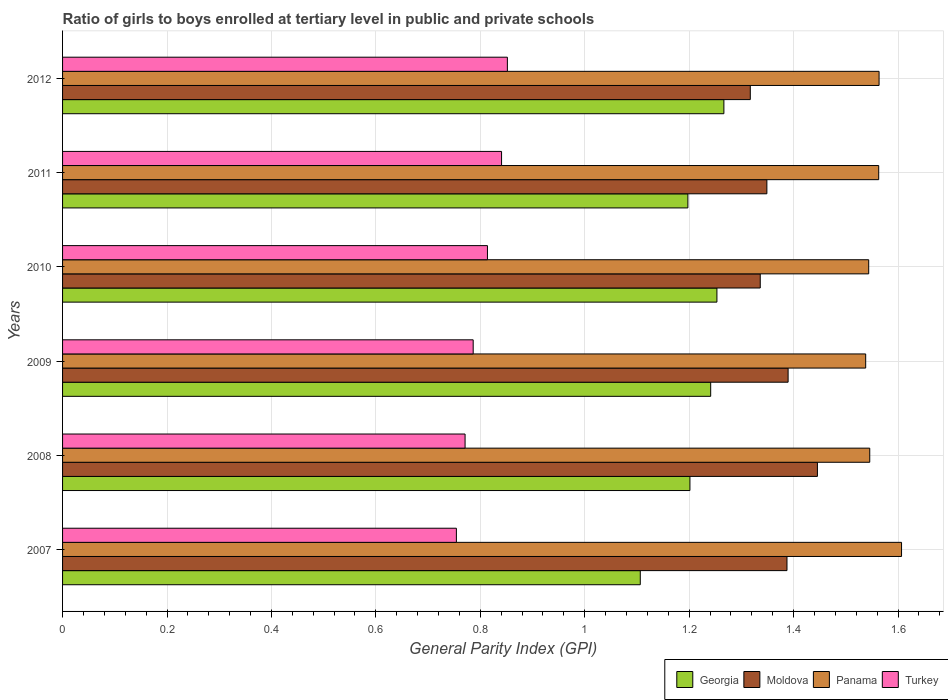How many different coloured bars are there?
Your response must be concise. 4. How many bars are there on the 5th tick from the top?
Ensure brevity in your answer.  4. How many bars are there on the 6th tick from the bottom?
Your response must be concise. 4. What is the label of the 1st group of bars from the top?
Offer a very short reply. 2012. In how many cases, is the number of bars for a given year not equal to the number of legend labels?
Make the answer very short. 0. What is the general parity index in Moldova in 2011?
Ensure brevity in your answer.  1.35. Across all years, what is the maximum general parity index in Moldova?
Make the answer very short. 1.45. Across all years, what is the minimum general parity index in Panama?
Make the answer very short. 1.54. In which year was the general parity index in Moldova maximum?
Keep it short and to the point. 2008. What is the total general parity index in Turkey in the graph?
Your answer should be compact. 4.82. What is the difference between the general parity index in Georgia in 2007 and that in 2012?
Offer a terse response. -0.16. What is the difference between the general parity index in Georgia in 2008 and the general parity index in Turkey in 2012?
Keep it short and to the point. 0.35. What is the average general parity index in Panama per year?
Provide a short and direct response. 1.56. In the year 2007, what is the difference between the general parity index in Georgia and general parity index in Turkey?
Your answer should be compact. 0.35. In how many years, is the general parity index in Moldova greater than 0.48000000000000004 ?
Provide a succinct answer. 6. What is the ratio of the general parity index in Georgia in 2007 to that in 2011?
Make the answer very short. 0.92. What is the difference between the highest and the second highest general parity index in Turkey?
Your response must be concise. 0.01. What is the difference between the highest and the lowest general parity index in Panama?
Give a very brief answer. 0.07. Is it the case that in every year, the sum of the general parity index in Georgia and general parity index in Moldova is greater than the sum of general parity index in Panama and general parity index in Turkey?
Provide a succinct answer. Yes. What does the 4th bar from the top in 2010 represents?
Provide a short and direct response. Georgia. What does the 2nd bar from the bottom in 2010 represents?
Offer a very short reply. Moldova. Are the values on the major ticks of X-axis written in scientific E-notation?
Your response must be concise. No. Does the graph contain any zero values?
Provide a succinct answer. No. Does the graph contain grids?
Provide a short and direct response. Yes. How are the legend labels stacked?
Offer a very short reply. Horizontal. What is the title of the graph?
Your answer should be compact. Ratio of girls to boys enrolled at tertiary level in public and private schools. What is the label or title of the X-axis?
Provide a short and direct response. General Parity Index (GPI). What is the label or title of the Y-axis?
Make the answer very short. Years. What is the General Parity Index (GPI) of Georgia in 2007?
Your answer should be compact. 1.11. What is the General Parity Index (GPI) in Moldova in 2007?
Make the answer very short. 1.39. What is the General Parity Index (GPI) in Panama in 2007?
Provide a short and direct response. 1.61. What is the General Parity Index (GPI) of Turkey in 2007?
Give a very brief answer. 0.75. What is the General Parity Index (GPI) in Georgia in 2008?
Make the answer very short. 1.2. What is the General Parity Index (GPI) in Moldova in 2008?
Keep it short and to the point. 1.45. What is the General Parity Index (GPI) of Panama in 2008?
Give a very brief answer. 1.55. What is the General Parity Index (GPI) in Turkey in 2008?
Your answer should be compact. 0.77. What is the General Parity Index (GPI) in Georgia in 2009?
Your answer should be compact. 1.24. What is the General Parity Index (GPI) of Moldova in 2009?
Offer a very short reply. 1.39. What is the General Parity Index (GPI) of Panama in 2009?
Your answer should be compact. 1.54. What is the General Parity Index (GPI) in Turkey in 2009?
Provide a short and direct response. 0.79. What is the General Parity Index (GPI) of Georgia in 2010?
Your response must be concise. 1.25. What is the General Parity Index (GPI) of Moldova in 2010?
Keep it short and to the point. 1.34. What is the General Parity Index (GPI) of Panama in 2010?
Your answer should be very brief. 1.54. What is the General Parity Index (GPI) in Turkey in 2010?
Give a very brief answer. 0.81. What is the General Parity Index (GPI) of Georgia in 2011?
Give a very brief answer. 1.2. What is the General Parity Index (GPI) of Moldova in 2011?
Offer a very short reply. 1.35. What is the General Parity Index (GPI) of Panama in 2011?
Ensure brevity in your answer.  1.56. What is the General Parity Index (GPI) in Turkey in 2011?
Offer a very short reply. 0.84. What is the General Parity Index (GPI) of Georgia in 2012?
Offer a very short reply. 1.27. What is the General Parity Index (GPI) in Moldova in 2012?
Your response must be concise. 1.32. What is the General Parity Index (GPI) of Panama in 2012?
Provide a succinct answer. 1.56. What is the General Parity Index (GPI) in Turkey in 2012?
Provide a short and direct response. 0.85. Across all years, what is the maximum General Parity Index (GPI) in Georgia?
Your response must be concise. 1.27. Across all years, what is the maximum General Parity Index (GPI) of Moldova?
Ensure brevity in your answer.  1.45. Across all years, what is the maximum General Parity Index (GPI) of Panama?
Offer a terse response. 1.61. Across all years, what is the maximum General Parity Index (GPI) in Turkey?
Provide a short and direct response. 0.85. Across all years, what is the minimum General Parity Index (GPI) in Georgia?
Offer a terse response. 1.11. Across all years, what is the minimum General Parity Index (GPI) in Moldova?
Provide a succinct answer. 1.32. Across all years, what is the minimum General Parity Index (GPI) of Panama?
Give a very brief answer. 1.54. Across all years, what is the minimum General Parity Index (GPI) in Turkey?
Provide a short and direct response. 0.75. What is the total General Parity Index (GPI) in Georgia in the graph?
Give a very brief answer. 7.27. What is the total General Parity Index (GPI) in Moldova in the graph?
Provide a succinct answer. 8.22. What is the total General Parity Index (GPI) of Panama in the graph?
Offer a terse response. 9.36. What is the total General Parity Index (GPI) in Turkey in the graph?
Provide a succinct answer. 4.82. What is the difference between the General Parity Index (GPI) of Georgia in 2007 and that in 2008?
Your response must be concise. -0.1. What is the difference between the General Parity Index (GPI) in Moldova in 2007 and that in 2008?
Your response must be concise. -0.06. What is the difference between the General Parity Index (GPI) of Panama in 2007 and that in 2008?
Your answer should be compact. 0.06. What is the difference between the General Parity Index (GPI) in Turkey in 2007 and that in 2008?
Make the answer very short. -0.02. What is the difference between the General Parity Index (GPI) of Georgia in 2007 and that in 2009?
Give a very brief answer. -0.13. What is the difference between the General Parity Index (GPI) of Moldova in 2007 and that in 2009?
Provide a succinct answer. -0. What is the difference between the General Parity Index (GPI) in Panama in 2007 and that in 2009?
Make the answer very short. 0.07. What is the difference between the General Parity Index (GPI) of Turkey in 2007 and that in 2009?
Offer a very short reply. -0.03. What is the difference between the General Parity Index (GPI) of Georgia in 2007 and that in 2010?
Ensure brevity in your answer.  -0.15. What is the difference between the General Parity Index (GPI) in Moldova in 2007 and that in 2010?
Provide a succinct answer. 0.05. What is the difference between the General Parity Index (GPI) in Panama in 2007 and that in 2010?
Your answer should be very brief. 0.06. What is the difference between the General Parity Index (GPI) of Turkey in 2007 and that in 2010?
Keep it short and to the point. -0.06. What is the difference between the General Parity Index (GPI) in Georgia in 2007 and that in 2011?
Offer a very short reply. -0.09. What is the difference between the General Parity Index (GPI) in Moldova in 2007 and that in 2011?
Give a very brief answer. 0.04. What is the difference between the General Parity Index (GPI) of Panama in 2007 and that in 2011?
Ensure brevity in your answer.  0.04. What is the difference between the General Parity Index (GPI) in Turkey in 2007 and that in 2011?
Your answer should be compact. -0.09. What is the difference between the General Parity Index (GPI) in Georgia in 2007 and that in 2012?
Make the answer very short. -0.16. What is the difference between the General Parity Index (GPI) in Moldova in 2007 and that in 2012?
Keep it short and to the point. 0.07. What is the difference between the General Parity Index (GPI) of Panama in 2007 and that in 2012?
Make the answer very short. 0.04. What is the difference between the General Parity Index (GPI) in Turkey in 2007 and that in 2012?
Your response must be concise. -0.1. What is the difference between the General Parity Index (GPI) in Georgia in 2008 and that in 2009?
Give a very brief answer. -0.04. What is the difference between the General Parity Index (GPI) in Moldova in 2008 and that in 2009?
Offer a terse response. 0.06. What is the difference between the General Parity Index (GPI) of Panama in 2008 and that in 2009?
Give a very brief answer. 0.01. What is the difference between the General Parity Index (GPI) in Turkey in 2008 and that in 2009?
Make the answer very short. -0.02. What is the difference between the General Parity Index (GPI) in Georgia in 2008 and that in 2010?
Ensure brevity in your answer.  -0.05. What is the difference between the General Parity Index (GPI) of Moldova in 2008 and that in 2010?
Ensure brevity in your answer.  0.11. What is the difference between the General Parity Index (GPI) in Panama in 2008 and that in 2010?
Ensure brevity in your answer.  0. What is the difference between the General Parity Index (GPI) in Turkey in 2008 and that in 2010?
Your answer should be compact. -0.04. What is the difference between the General Parity Index (GPI) of Georgia in 2008 and that in 2011?
Your answer should be compact. 0. What is the difference between the General Parity Index (GPI) of Moldova in 2008 and that in 2011?
Provide a short and direct response. 0.1. What is the difference between the General Parity Index (GPI) in Panama in 2008 and that in 2011?
Ensure brevity in your answer.  -0.02. What is the difference between the General Parity Index (GPI) of Turkey in 2008 and that in 2011?
Give a very brief answer. -0.07. What is the difference between the General Parity Index (GPI) in Georgia in 2008 and that in 2012?
Your answer should be compact. -0.07. What is the difference between the General Parity Index (GPI) of Moldova in 2008 and that in 2012?
Offer a terse response. 0.13. What is the difference between the General Parity Index (GPI) of Panama in 2008 and that in 2012?
Your answer should be very brief. -0.02. What is the difference between the General Parity Index (GPI) in Turkey in 2008 and that in 2012?
Make the answer very short. -0.08. What is the difference between the General Parity Index (GPI) in Georgia in 2009 and that in 2010?
Ensure brevity in your answer.  -0.01. What is the difference between the General Parity Index (GPI) of Moldova in 2009 and that in 2010?
Your answer should be very brief. 0.05. What is the difference between the General Parity Index (GPI) in Panama in 2009 and that in 2010?
Provide a succinct answer. -0.01. What is the difference between the General Parity Index (GPI) of Turkey in 2009 and that in 2010?
Your answer should be compact. -0.03. What is the difference between the General Parity Index (GPI) in Georgia in 2009 and that in 2011?
Your answer should be very brief. 0.04. What is the difference between the General Parity Index (GPI) in Moldova in 2009 and that in 2011?
Ensure brevity in your answer.  0.04. What is the difference between the General Parity Index (GPI) of Panama in 2009 and that in 2011?
Provide a succinct answer. -0.02. What is the difference between the General Parity Index (GPI) in Turkey in 2009 and that in 2011?
Offer a terse response. -0.05. What is the difference between the General Parity Index (GPI) in Georgia in 2009 and that in 2012?
Make the answer very short. -0.03. What is the difference between the General Parity Index (GPI) of Moldova in 2009 and that in 2012?
Provide a succinct answer. 0.07. What is the difference between the General Parity Index (GPI) in Panama in 2009 and that in 2012?
Your answer should be compact. -0.03. What is the difference between the General Parity Index (GPI) of Turkey in 2009 and that in 2012?
Give a very brief answer. -0.07. What is the difference between the General Parity Index (GPI) in Georgia in 2010 and that in 2011?
Offer a very short reply. 0.06. What is the difference between the General Parity Index (GPI) of Moldova in 2010 and that in 2011?
Your answer should be very brief. -0.01. What is the difference between the General Parity Index (GPI) of Panama in 2010 and that in 2011?
Provide a succinct answer. -0.02. What is the difference between the General Parity Index (GPI) of Turkey in 2010 and that in 2011?
Your answer should be compact. -0.03. What is the difference between the General Parity Index (GPI) in Georgia in 2010 and that in 2012?
Your answer should be compact. -0.01. What is the difference between the General Parity Index (GPI) of Moldova in 2010 and that in 2012?
Ensure brevity in your answer.  0.02. What is the difference between the General Parity Index (GPI) in Panama in 2010 and that in 2012?
Your answer should be compact. -0.02. What is the difference between the General Parity Index (GPI) of Turkey in 2010 and that in 2012?
Make the answer very short. -0.04. What is the difference between the General Parity Index (GPI) in Georgia in 2011 and that in 2012?
Keep it short and to the point. -0.07. What is the difference between the General Parity Index (GPI) of Moldova in 2011 and that in 2012?
Your response must be concise. 0.03. What is the difference between the General Parity Index (GPI) in Panama in 2011 and that in 2012?
Offer a terse response. -0. What is the difference between the General Parity Index (GPI) of Turkey in 2011 and that in 2012?
Provide a short and direct response. -0.01. What is the difference between the General Parity Index (GPI) in Georgia in 2007 and the General Parity Index (GPI) in Moldova in 2008?
Your response must be concise. -0.34. What is the difference between the General Parity Index (GPI) of Georgia in 2007 and the General Parity Index (GPI) of Panama in 2008?
Make the answer very short. -0.44. What is the difference between the General Parity Index (GPI) of Georgia in 2007 and the General Parity Index (GPI) of Turkey in 2008?
Offer a terse response. 0.34. What is the difference between the General Parity Index (GPI) in Moldova in 2007 and the General Parity Index (GPI) in Panama in 2008?
Provide a succinct answer. -0.16. What is the difference between the General Parity Index (GPI) in Moldova in 2007 and the General Parity Index (GPI) in Turkey in 2008?
Provide a succinct answer. 0.62. What is the difference between the General Parity Index (GPI) of Panama in 2007 and the General Parity Index (GPI) of Turkey in 2008?
Ensure brevity in your answer.  0.84. What is the difference between the General Parity Index (GPI) of Georgia in 2007 and the General Parity Index (GPI) of Moldova in 2009?
Offer a terse response. -0.28. What is the difference between the General Parity Index (GPI) in Georgia in 2007 and the General Parity Index (GPI) in Panama in 2009?
Offer a very short reply. -0.43. What is the difference between the General Parity Index (GPI) of Georgia in 2007 and the General Parity Index (GPI) of Turkey in 2009?
Your response must be concise. 0.32. What is the difference between the General Parity Index (GPI) of Moldova in 2007 and the General Parity Index (GPI) of Panama in 2009?
Make the answer very short. -0.15. What is the difference between the General Parity Index (GPI) in Moldova in 2007 and the General Parity Index (GPI) in Turkey in 2009?
Offer a very short reply. 0.6. What is the difference between the General Parity Index (GPI) in Panama in 2007 and the General Parity Index (GPI) in Turkey in 2009?
Your answer should be compact. 0.82. What is the difference between the General Parity Index (GPI) of Georgia in 2007 and the General Parity Index (GPI) of Moldova in 2010?
Offer a terse response. -0.23. What is the difference between the General Parity Index (GPI) of Georgia in 2007 and the General Parity Index (GPI) of Panama in 2010?
Give a very brief answer. -0.44. What is the difference between the General Parity Index (GPI) of Georgia in 2007 and the General Parity Index (GPI) of Turkey in 2010?
Provide a short and direct response. 0.29. What is the difference between the General Parity Index (GPI) in Moldova in 2007 and the General Parity Index (GPI) in Panama in 2010?
Provide a short and direct response. -0.16. What is the difference between the General Parity Index (GPI) in Moldova in 2007 and the General Parity Index (GPI) in Turkey in 2010?
Offer a terse response. 0.57. What is the difference between the General Parity Index (GPI) in Panama in 2007 and the General Parity Index (GPI) in Turkey in 2010?
Offer a terse response. 0.79. What is the difference between the General Parity Index (GPI) of Georgia in 2007 and the General Parity Index (GPI) of Moldova in 2011?
Keep it short and to the point. -0.24. What is the difference between the General Parity Index (GPI) of Georgia in 2007 and the General Parity Index (GPI) of Panama in 2011?
Make the answer very short. -0.46. What is the difference between the General Parity Index (GPI) of Georgia in 2007 and the General Parity Index (GPI) of Turkey in 2011?
Ensure brevity in your answer.  0.27. What is the difference between the General Parity Index (GPI) in Moldova in 2007 and the General Parity Index (GPI) in Panama in 2011?
Ensure brevity in your answer.  -0.18. What is the difference between the General Parity Index (GPI) in Moldova in 2007 and the General Parity Index (GPI) in Turkey in 2011?
Make the answer very short. 0.55. What is the difference between the General Parity Index (GPI) in Panama in 2007 and the General Parity Index (GPI) in Turkey in 2011?
Ensure brevity in your answer.  0.77. What is the difference between the General Parity Index (GPI) of Georgia in 2007 and the General Parity Index (GPI) of Moldova in 2012?
Provide a succinct answer. -0.21. What is the difference between the General Parity Index (GPI) of Georgia in 2007 and the General Parity Index (GPI) of Panama in 2012?
Provide a short and direct response. -0.46. What is the difference between the General Parity Index (GPI) in Georgia in 2007 and the General Parity Index (GPI) in Turkey in 2012?
Offer a very short reply. 0.25. What is the difference between the General Parity Index (GPI) in Moldova in 2007 and the General Parity Index (GPI) in Panama in 2012?
Ensure brevity in your answer.  -0.18. What is the difference between the General Parity Index (GPI) in Moldova in 2007 and the General Parity Index (GPI) in Turkey in 2012?
Offer a very short reply. 0.54. What is the difference between the General Parity Index (GPI) in Panama in 2007 and the General Parity Index (GPI) in Turkey in 2012?
Make the answer very short. 0.75. What is the difference between the General Parity Index (GPI) in Georgia in 2008 and the General Parity Index (GPI) in Moldova in 2009?
Ensure brevity in your answer.  -0.19. What is the difference between the General Parity Index (GPI) of Georgia in 2008 and the General Parity Index (GPI) of Panama in 2009?
Your response must be concise. -0.34. What is the difference between the General Parity Index (GPI) in Georgia in 2008 and the General Parity Index (GPI) in Turkey in 2009?
Your answer should be compact. 0.42. What is the difference between the General Parity Index (GPI) in Moldova in 2008 and the General Parity Index (GPI) in Panama in 2009?
Make the answer very short. -0.09. What is the difference between the General Parity Index (GPI) in Moldova in 2008 and the General Parity Index (GPI) in Turkey in 2009?
Provide a short and direct response. 0.66. What is the difference between the General Parity Index (GPI) of Panama in 2008 and the General Parity Index (GPI) of Turkey in 2009?
Make the answer very short. 0.76. What is the difference between the General Parity Index (GPI) of Georgia in 2008 and the General Parity Index (GPI) of Moldova in 2010?
Offer a terse response. -0.13. What is the difference between the General Parity Index (GPI) of Georgia in 2008 and the General Parity Index (GPI) of Panama in 2010?
Ensure brevity in your answer.  -0.34. What is the difference between the General Parity Index (GPI) of Georgia in 2008 and the General Parity Index (GPI) of Turkey in 2010?
Offer a terse response. 0.39. What is the difference between the General Parity Index (GPI) in Moldova in 2008 and the General Parity Index (GPI) in Panama in 2010?
Provide a succinct answer. -0.1. What is the difference between the General Parity Index (GPI) of Moldova in 2008 and the General Parity Index (GPI) of Turkey in 2010?
Give a very brief answer. 0.63. What is the difference between the General Parity Index (GPI) in Panama in 2008 and the General Parity Index (GPI) in Turkey in 2010?
Offer a very short reply. 0.73. What is the difference between the General Parity Index (GPI) in Georgia in 2008 and the General Parity Index (GPI) in Moldova in 2011?
Provide a succinct answer. -0.15. What is the difference between the General Parity Index (GPI) of Georgia in 2008 and the General Parity Index (GPI) of Panama in 2011?
Ensure brevity in your answer.  -0.36. What is the difference between the General Parity Index (GPI) in Georgia in 2008 and the General Parity Index (GPI) in Turkey in 2011?
Make the answer very short. 0.36. What is the difference between the General Parity Index (GPI) of Moldova in 2008 and the General Parity Index (GPI) of Panama in 2011?
Offer a very short reply. -0.12. What is the difference between the General Parity Index (GPI) in Moldova in 2008 and the General Parity Index (GPI) in Turkey in 2011?
Give a very brief answer. 0.6. What is the difference between the General Parity Index (GPI) of Panama in 2008 and the General Parity Index (GPI) of Turkey in 2011?
Offer a terse response. 0.71. What is the difference between the General Parity Index (GPI) in Georgia in 2008 and the General Parity Index (GPI) in Moldova in 2012?
Provide a succinct answer. -0.12. What is the difference between the General Parity Index (GPI) of Georgia in 2008 and the General Parity Index (GPI) of Panama in 2012?
Ensure brevity in your answer.  -0.36. What is the difference between the General Parity Index (GPI) in Georgia in 2008 and the General Parity Index (GPI) in Turkey in 2012?
Your answer should be very brief. 0.35. What is the difference between the General Parity Index (GPI) in Moldova in 2008 and the General Parity Index (GPI) in Panama in 2012?
Offer a very short reply. -0.12. What is the difference between the General Parity Index (GPI) in Moldova in 2008 and the General Parity Index (GPI) in Turkey in 2012?
Provide a succinct answer. 0.59. What is the difference between the General Parity Index (GPI) in Panama in 2008 and the General Parity Index (GPI) in Turkey in 2012?
Your answer should be compact. 0.69. What is the difference between the General Parity Index (GPI) of Georgia in 2009 and the General Parity Index (GPI) of Moldova in 2010?
Your answer should be compact. -0.09. What is the difference between the General Parity Index (GPI) in Georgia in 2009 and the General Parity Index (GPI) in Panama in 2010?
Give a very brief answer. -0.3. What is the difference between the General Parity Index (GPI) of Georgia in 2009 and the General Parity Index (GPI) of Turkey in 2010?
Offer a very short reply. 0.43. What is the difference between the General Parity Index (GPI) of Moldova in 2009 and the General Parity Index (GPI) of Panama in 2010?
Keep it short and to the point. -0.15. What is the difference between the General Parity Index (GPI) in Moldova in 2009 and the General Parity Index (GPI) in Turkey in 2010?
Your response must be concise. 0.58. What is the difference between the General Parity Index (GPI) of Panama in 2009 and the General Parity Index (GPI) of Turkey in 2010?
Give a very brief answer. 0.72. What is the difference between the General Parity Index (GPI) in Georgia in 2009 and the General Parity Index (GPI) in Moldova in 2011?
Give a very brief answer. -0.11. What is the difference between the General Parity Index (GPI) in Georgia in 2009 and the General Parity Index (GPI) in Panama in 2011?
Offer a very short reply. -0.32. What is the difference between the General Parity Index (GPI) of Georgia in 2009 and the General Parity Index (GPI) of Turkey in 2011?
Provide a succinct answer. 0.4. What is the difference between the General Parity Index (GPI) of Moldova in 2009 and the General Parity Index (GPI) of Panama in 2011?
Make the answer very short. -0.17. What is the difference between the General Parity Index (GPI) in Moldova in 2009 and the General Parity Index (GPI) in Turkey in 2011?
Ensure brevity in your answer.  0.55. What is the difference between the General Parity Index (GPI) of Panama in 2009 and the General Parity Index (GPI) of Turkey in 2011?
Your response must be concise. 0.7. What is the difference between the General Parity Index (GPI) of Georgia in 2009 and the General Parity Index (GPI) of Moldova in 2012?
Your answer should be compact. -0.08. What is the difference between the General Parity Index (GPI) of Georgia in 2009 and the General Parity Index (GPI) of Panama in 2012?
Your answer should be compact. -0.32. What is the difference between the General Parity Index (GPI) of Georgia in 2009 and the General Parity Index (GPI) of Turkey in 2012?
Your response must be concise. 0.39. What is the difference between the General Parity Index (GPI) of Moldova in 2009 and the General Parity Index (GPI) of Panama in 2012?
Make the answer very short. -0.17. What is the difference between the General Parity Index (GPI) in Moldova in 2009 and the General Parity Index (GPI) in Turkey in 2012?
Offer a terse response. 0.54. What is the difference between the General Parity Index (GPI) in Panama in 2009 and the General Parity Index (GPI) in Turkey in 2012?
Provide a succinct answer. 0.69. What is the difference between the General Parity Index (GPI) of Georgia in 2010 and the General Parity Index (GPI) of Moldova in 2011?
Offer a terse response. -0.1. What is the difference between the General Parity Index (GPI) of Georgia in 2010 and the General Parity Index (GPI) of Panama in 2011?
Provide a short and direct response. -0.31. What is the difference between the General Parity Index (GPI) in Georgia in 2010 and the General Parity Index (GPI) in Turkey in 2011?
Offer a terse response. 0.41. What is the difference between the General Parity Index (GPI) of Moldova in 2010 and the General Parity Index (GPI) of Panama in 2011?
Your answer should be compact. -0.23. What is the difference between the General Parity Index (GPI) of Moldova in 2010 and the General Parity Index (GPI) of Turkey in 2011?
Keep it short and to the point. 0.5. What is the difference between the General Parity Index (GPI) in Panama in 2010 and the General Parity Index (GPI) in Turkey in 2011?
Your answer should be very brief. 0.7. What is the difference between the General Parity Index (GPI) in Georgia in 2010 and the General Parity Index (GPI) in Moldova in 2012?
Give a very brief answer. -0.06. What is the difference between the General Parity Index (GPI) in Georgia in 2010 and the General Parity Index (GPI) in Panama in 2012?
Make the answer very short. -0.31. What is the difference between the General Parity Index (GPI) in Georgia in 2010 and the General Parity Index (GPI) in Turkey in 2012?
Your response must be concise. 0.4. What is the difference between the General Parity Index (GPI) of Moldova in 2010 and the General Parity Index (GPI) of Panama in 2012?
Keep it short and to the point. -0.23. What is the difference between the General Parity Index (GPI) of Moldova in 2010 and the General Parity Index (GPI) of Turkey in 2012?
Your response must be concise. 0.48. What is the difference between the General Parity Index (GPI) in Panama in 2010 and the General Parity Index (GPI) in Turkey in 2012?
Keep it short and to the point. 0.69. What is the difference between the General Parity Index (GPI) of Georgia in 2011 and the General Parity Index (GPI) of Moldova in 2012?
Ensure brevity in your answer.  -0.12. What is the difference between the General Parity Index (GPI) of Georgia in 2011 and the General Parity Index (GPI) of Panama in 2012?
Offer a very short reply. -0.37. What is the difference between the General Parity Index (GPI) in Georgia in 2011 and the General Parity Index (GPI) in Turkey in 2012?
Provide a succinct answer. 0.35. What is the difference between the General Parity Index (GPI) in Moldova in 2011 and the General Parity Index (GPI) in Panama in 2012?
Ensure brevity in your answer.  -0.21. What is the difference between the General Parity Index (GPI) in Moldova in 2011 and the General Parity Index (GPI) in Turkey in 2012?
Make the answer very short. 0.5. What is the difference between the General Parity Index (GPI) in Panama in 2011 and the General Parity Index (GPI) in Turkey in 2012?
Provide a short and direct response. 0.71. What is the average General Parity Index (GPI) in Georgia per year?
Your answer should be very brief. 1.21. What is the average General Parity Index (GPI) of Moldova per year?
Offer a terse response. 1.37. What is the average General Parity Index (GPI) of Panama per year?
Ensure brevity in your answer.  1.56. What is the average General Parity Index (GPI) in Turkey per year?
Your answer should be compact. 0.8. In the year 2007, what is the difference between the General Parity Index (GPI) of Georgia and General Parity Index (GPI) of Moldova?
Make the answer very short. -0.28. In the year 2007, what is the difference between the General Parity Index (GPI) in Georgia and General Parity Index (GPI) in Panama?
Provide a short and direct response. -0.5. In the year 2007, what is the difference between the General Parity Index (GPI) in Georgia and General Parity Index (GPI) in Turkey?
Give a very brief answer. 0.35. In the year 2007, what is the difference between the General Parity Index (GPI) in Moldova and General Parity Index (GPI) in Panama?
Ensure brevity in your answer.  -0.22. In the year 2007, what is the difference between the General Parity Index (GPI) in Moldova and General Parity Index (GPI) in Turkey?
Your answer should be compact. 0.63. In the year 2007, what is the difference between the General Parity Index (GPI) of Panama and General Parity Index (GPI) of Turkey?
Give a very brief answer. 0.85. In the year 2008, what is the difference between the General Parity Index (GPI) of Georgia and General Parity Index (GPI) of Moldova?
Give a very brief answer. -0.24. In the year 2008, what is the difference between the General Parity Index (GPI) in Georgia and General Parity Index (GPI) in Panama?
Give a very brief answer. -0.34. In the year 2008, what is the difference between the General Parity Index (GPI) in Georgia and General Parity Index (GPI) in Turkey?
Give a very brief answer. 0.43. In the year 2008, what is the difference between the General Parity Index (GPI) in Moldova and General Parity Index (GPI) in Panama?
Ensure brevity in your answer.  -0.1. In the year 2008, what is the difference between the General Parity Index (GPI) of Moldova and General Parity Index (GPI) of Turkey?
Ensure brevity in your answer.  0.67. In the year 2008, what is the difference between the General Parity Index (GPI) of Panama and General Parity Index (GPI) of Turkey?
Offer a very short reply. 0.78. In the year 2009, what is the difference between the General Parity Index (GPI) of Georgia and General Parity Index (GPI) of Moldova?
Your answer should be very brief. -0.15. In the year 2009, what is the difference between the General Parity Index (GPI) in Georgia and General Parity Index (GPI) in Panama?
Offer a terse response. -0.3. In the year 2009, what is the difference between the General Parity Index (GPI) of Georgia and General Parity Index (GPI) of Turkey?
Your answer should be very brief. 0.45. In the year 2009, what is the difference between the General Parity Index (GPI) of Moldova and General Parity Index (GPI) of Panama?
Keep it short and to the point. -0.15. In the year 2009, what is the difference between the General Parity Index (GPI) of Moldova and General Parity Index (GPI) of Turkey?
Give a very brief answer. 0.6. In the year 2009, what is the difference between the General Parity Index (GPI) in Panama and General Parity Index (GPI) in Turkey?
Your answer should be very brief. 0.75. In the year 2010, what is the difference between the General Parity Index (GPI) in Georgia and General Parity Index (GPI) in Moldova?
Provide a short and direct response. -0.08. In the year 2010, what is the difference between the General Parity Index (GPI) of Georgia and General Parity Index (GPI) of Panama?
Give a very brief answer. -0.29. In the year 2010, what is the difference between the General Parity Index (GPI) of Georgia and General Parity Index (GPI) of Turkey?
Provide a succinct answer. 0.44. In the year 2010, what is the difference between the General Parity Index (GPI) in Moldova and General Parity Index (GPI) in Panama?
Your response must be concise. -0.21. In the year 2010, what is the difference between the General Parity Index (GPI) of Moldova and General Parity Index (GPI) of Turkey?
Keep it short and to the point. 0.52. In the year 2010, what is the difference between the General Parity Index (GPI) of Panama and General Parity Index (GPI) of Turkey?
Ensure brevity in your answer.  0.73. In the year 2011, what is the difference between the General Parity Index (GPI) in Georgia and General Parity Index (GPI) in Moldova?
Make the answer very short. -0.15. In the year 2011, what is the difference between the General Parity Index (GPI) in Georgia and General Parity Index (GPI) in Panama?
Your response must be concise. -0.37. In the year 2011, what is the difference between the General Parity Index (GPI) in Georgia and General Parity Index (GPI) in Turkey?
Give a very brief answer. 0.36. In the year 2011, what is the difference between the General Parity Index (GPI) in Moldova and General Parity Index (GPI) in Panama?
Offer a terse response. -0.21. In the year 2011, what is the difference between the General Parity Index (GPI) in Moldova and General Parity Index (GPI) in Turkey?
Give a very brief answer. 0.51. In the year 2011, what is the difference between the General Parity Index (GPI) of Panama and General Parity Index (GPI) of Turkey?
Your answer should be very brief. 0.72. In the year 2012, what is the difference between the General Parity Index (GPI) of Georgia and General Parity Index (GPI) of Moldova?
Your answer should be very brief. -0.05. In the year 2012, what is the difference between the General Parity Index (GPI) in Georgia and General Parity Index (GPI) in Panama?
Offer a very short reply. -0.3. In the year 2012, what is the difference between the General Parity Index (GPI) of Georgia and General Parity Index (GPI) of Turkey?
Offer a very short reply. 0.41. In the year 2012, what is the difference between the General Parity Index (GPI) in Moldova and General Parity Index (GPI) in Panama?
Ensure brevity in your answer.  -0.25. In the year 2012, what is the difference between the General Parity Index (GPI) in Moldova and General Parity Index (GPI) in Turkey?
Provide a short and direct response. 0.47. In the year 2012, what is the difference between the General Parity Index (GPI) of Panama and General Parity Index (GPI) of Turkey?
Your answer should be compact. 0.71. What is the ratio of the General Parity Index (GPI) in Georgia in 2007 to that in 2008?
Make the answer very short. 0.92. What is the ratio of the General Parity Index (GPI) of Moldova in 2007 to that in 2008?
Give a very brief answer. 0.96. What is the ratio of the General Parity Index (GPI) in Panama in 2007 to that in 2008?
Make the answer very short. 1.04. What is the ratio of the General Parity Index (GPI) of Turkey in 2007 to that in 2008?
Your answer should be compact. 0.98. What is the ratio of the General Parity Index (GPI) in Georgia in 2007 to that in 2009?
Your answer should be very brief. 0.89. What is the ratio of the General Parity Index (GPI) of Moldova in 2007 to that in 2009?
Provide a short and direct response. 1. What is the ratio of the General Parity Index (GPI) in Panama in 2007 to that in 2009?
Provide a short and direct response. 1.04. What is the ratio of the General Parity Index (GPI) in Turkey in 2007 to that in 2009?
Ensure brevity in your answer.  0.96. What is the ratio of the General Parity Index (GPI) of Georgia in 2007 to that in 2010?
Your response must be concise. 0.88. What is the ratio of the General Parity Index (GPI) in Moldova in 2007 to that in 2010?
Offer a very short reply. 1.04. What is the ratio of the General Parity Index (GPI) in Panama in 2007 to that in 2010?
Offer a very short reply. 1.04. What is the ratio of the General Parity Index (GPI) in Turkey in 2007 to that in 2010?
Ensure brevity in your answer.  0.93. What is the ratio of the General Parity Index (GPI) in Georgia in 2007 to that in 2011?
Provide a succinct answer. 0.92. What is the ratio of the General Parity Index (GPI) of Moldova in 2007 to that in 2011?
Offer a very short reply. 1.03. What is the ratio of the General Parity Index (GPI) in Panama in 2007 to that in 2011?
Provide a succinct answer. 1.03. What is the ratio of the General Parity Index (GPI) in Turkey in 2007 to that in 2011?
Your answer should be compact. 0.9. What is the ratio of the General Parity Index (GPI) of Georgia in 2007 to that in 2012?
Give a very brief answer. 0.87. What is the ratio of the General Parity Index (GPI) in Moldova in 2007 to that in 2012?
Give a very brief answer. 1.05. What is the ratio of the General Parity Index (GPI) of Panama in 2007 to that in 2012?
Offer a terse response. 1.03. What is the ratio of the General Parity Index (GPI) in Turkey in 2007 to that in 2012?
Offer a very short reply. 0.89. What is the ratio of the General Parity Index (GPI) of Georgia in 2008 to that in 2009?
Your response must be concise. 0.97. What is the ratio of the General Parity Index (GPI) of Moldova in 2008 to that in 2009?
Your response must be concise. 1.04. What is the ratio of the General Parity Index (GPI) of Panama in 2008 to that in 2009?
Keep it short and to the point. 1.01. What is the ratio of the General Parity Index (GPI) in Turkey in 2008 to that in 2009?
Make the answer very short. 0.98. What is the ratio of the General Parity Index (GPI) of Georgia in 2008 to that in 2010?
Ensure brevity in your answer.  0.96. What is the ratio of the General Parity Index (GPI) of Moldova in 2008 to that in 2010?
Provide a short and direct response. 1.08. What is the ratio of the General Parity Index (GPI) in Panama in 2008 to that in 2010?
Provide a short and direct response. 1. What is the ratio of the General Parity Index (GPI) in Turkey in 2008 to that in 2010?
Ensure brevity in your answer.  0.95. What is the ratio of the General Parity Index (GPI) of Georgia in 2008 to that in 2011?
Keep it short and to the point. 1. What is the ratio of the General Parity Index (GPI) of Moldova in 2008 to that in 2011?
Ensure brevity in your answer.  1.07. What is the ratio of the General Parity Index (GPI) in Panama in 2008 to that in 2011?
Your answer should be compact. 0.99. What is the ratio of the General Parity Index (GPI) of Turkey in 2008 to that in 2011?
Your answer should be very brief. 0.92. What is the ratio of the General Parity Index (GPI) of Georgia in 2008 to that in 2012?
Make the answer very short. 0.95. What is the ratio of the General Parity Index (GPI) in Moldova in 2008 to that in 2012?
Offer a terse response. 1.1. What is the ratio of the General Parity Index (GPI) of Turkey in 2008 to that in 2012?
Your response must be concise. 0.9. What is the ratio of the General Parity Index (GPI) of Georgia in 2009 to that in 2010?
Keep it short and to the point. 0.99. What is the ratio of the General Parity Index (GPI) in Moldova in 2009 to that in 2010?
Offer a terse response. 1.04. What is the ratio of the General Parity Index (GPI) of Panama in 2009 to that in 2010?
Make the answer very short. 1. What is the ratio of the General Parity Index (GPI) of Turkey in 2009 to that in 2010?
Make the answer very short. 0.97. What is the ratio of the General Parity Index (GPI) in Georgia in 2009 to that in 2011?
Your answer should be compact. 1.04. What is the ratio of the General Parity Index (GPI) in Moldova in 2009 to that in 2011?
Make the answer very short. 1.03. What is the ratio of the General Parity Index (GPI) of Panama in 2009 to that in 2011?
Give a very brief answer. 0.98. What is the ratio of the General Parity Index (GPI) of Turkey in 2009 to that in 2011?
Your response must be concise. 0.94. What is the ratio of the General Parity Index (GPI) of Georgia in 2009 to that in 2012?
Your response must be concise. 0.98. What is the ratio of the General Parity Index (GPI) of Moldova in 2009 to that in 2012?
Offer a very short reply. 1.05. What is the ratio of the General Parity Index (GPI) in Panama in 2009 to that in 2012?
Your answer should be compact. 0.98. What is the ratio of the General Parity Index (GPI) of Georgia in 2010 to that in 2011?
Offer a very short reply. 1.05. What is the ratio of the General Parity Index (GPI) of Moldova in 2010 to that in 2011?
Offer a terse response. 0.99. What is the ratio of the General Parity Index (GPI) of Panama in 2010 to that in 2011?
Offer a very short reply. 0.99. What is the ratio of the General Parity Index (GPI) of Turkey in 2010 to that in 2011?
Provide a short and direct response. 0.97. What is the ratio of the General Parity Index (GPI) in Georgia in 2010 to that in 2012?
Keep it short and to the point. 0.99. What is the ratio of the General Parity Index (GPI) of Moldova in 2010 to that in 2012?
Offer a very short reply. 1.01. What is the ratio of the General Parity Index (GPI) in Panama in 2010 to that in 2012?
Make the answer very short. 0.99. What is the ratio of the General Parity Index (GPI) in Turkey in 2010 to that in 2012?
Offer a terse response. 0.96. What is the ratio of the General Parity Index (GPI) in Georgia in 2011 to that in 2012?
Provide a succinct answer. 0.95. What is the ratio of the General Parity Index (GPI) of Moldova in 2011 to that in 2012?
Your answer should be compact. 1.02. What is the ratio of the General Parity Index (GPI) in Panama in 2011 to that in 2012?
Give a very brief answer. 1. What is the ratio of the General Parity Index (GPI) of Turkey in 2011 to that in 2012?
Offer a very short reply. 0.99. What is the difference between the highest and the second highest General Parity Index (GPI) in Georgia?
Offer a very short reply. 0.01. What is the difference between the highest and the second highest General Parity Index (GPI) in Moldova?
Provide a short and direct response. 0.06. What is the difference between the highest and the second highest General Parity Index (GPI) in Panama?
Make the answer very short. 0.04. What is the difference between the highest and the second highest General Parity Index (GPI) of Turkey?
Provide a succinct answer. 0.01. What is the difference between the highest and the lowest General Parity Index (GPI) of Georgia?
Your answer should be compact. 0.16. What is the difference between the highest and the lowest General Parity Index (GPI) of Moldova?
Keep it short and to the point. 0.13. What is the difference between the highest and the lowest General Parity Index (GPI) in Panama?
Offer a terse response. 0.07. What is the difference between the highest and the lowest General Parity Index (GPI) of Turkey?
Offer a terse response. 0.1. 